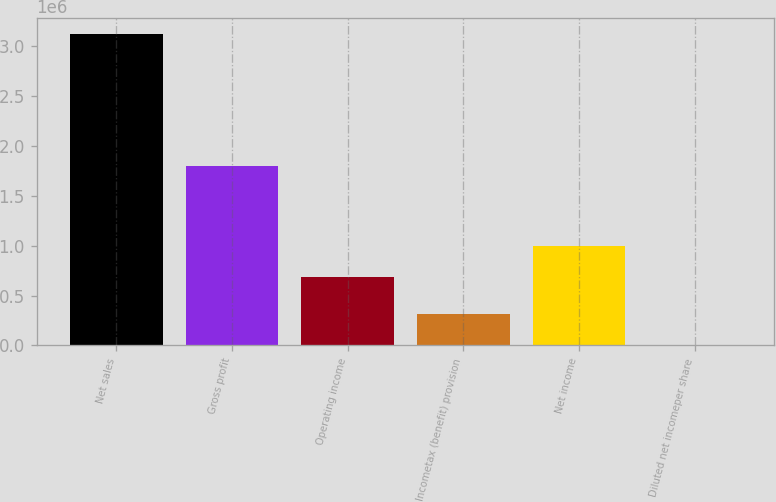Convert chart to OTSL. <chart><loc_0><loc_0><loc_500><loc_500><bar_chart><fcel>Net sales<fcel>Gross profit<fcel>Operating income<fcel>Incometax (benefit) provision<fcel>Net income<fcel>Diluted net incomeper share<nl><fcel>3.12156e+06<fcel>1.79794e+06<fcel>683637<fcel>312159<fcel>995793<fcel>3.76<nl></chart> 